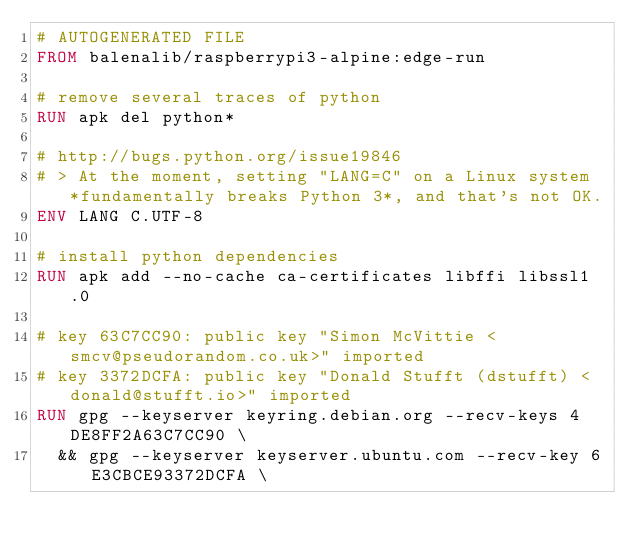<code> <loc_0><loc_0><loc_500><loc_500><_Dockerfile_># AUTOGENERATED FILE
FROM balenalib/raspberrypi3-alpine:edge-run

# remove several traces of python
RUN apk del python*

# http://bugs.python.org/issue19846
# > At the moment, setting "LANG=C" on a Linux system *fundamentally breaks Python 3*, and that's not OK.
ENV LANG C.UTF-8

# install python dependencies
RUN apk add --no-cache ca-certificates libffi libssl1.0

# key 63C7CC90: public key "Simon McVittie <smcv@pseudorandom.co.uk>" imported
# key 3372DCFA: public key "Donald Stufft (dstufft) <donald@stufft.io>" imported
RUN gpg --keyserver keyring.debian.org --recv-keys 4DE8FF2A63C7CC90 \
	&& gpg --keyserver keyserver.ubuntu.com --recv-key 6E3CBCE93372DCFA \</code> 